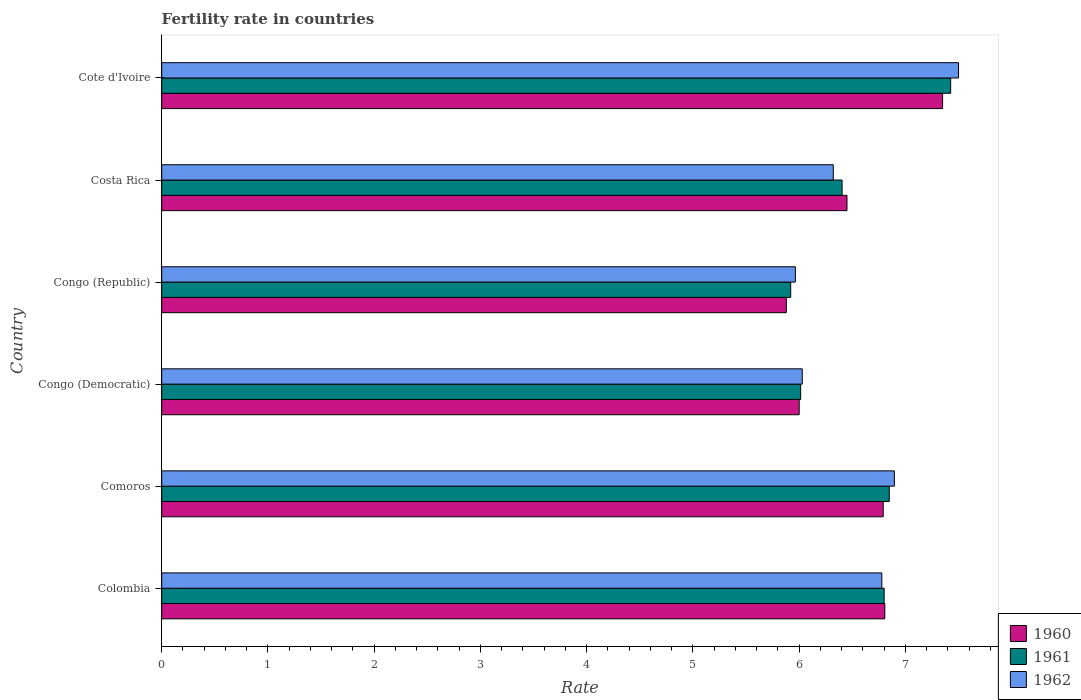How many different coloured bars are there?
Make the answer very short. 3. Are the number of bars per tick equal to the number of legend labels?
Your response must be concise. Yes. Are the number of bars on each tick of the Y-axis equal?
Make the answer very short. Yes. How many bars are there on the 6th tick from the bottom?
Offer a terse response. 3. What is the label of the 2nd group of bars from the top?
Provide a succinct answer. Costa Rica. What is the fertility rate in 1960 in Congo (Democratic)?
Ensure brevity in your answer.  6. Across all countries, what is the maximum fertility rate in 1960?
Your answer should be very brief. 7.35. Across all countries, what is the minimum fertility rate in 1961?
Provide a succinct answer. 5.92. In which country was the fertility rate in 1962 maximum?
Offer a very short reply. Cote d'Ivoire. In which country was the fertility rate in 1962 minimum?
Offer a terse response. Congo (Republic). What is the total fertility rate in 1960 in the graph?
Offer a very short reply. 39.28. What is the difference between the fertility rate in 1960 in Congo (Republic) and that in Costa Rica?
Provide a short and direct response. -0.57. What is the difference between the fertility rate in 1960 in Congo (Democratic) and the fertility rate in 1961 in Costa Rica?
Provide a succinct answer. -0.4. What is the average fertility rate in 1960 per country?
Offer a terse response. 6.55. What is the difference between the fertility rate in 1960 and fertility rate in 1961 in Costa Rica?
Offer a very short reply. 0.05. In how many countries, is the fertility rate in 1961 greater than 3.2 ?
Provide a short and direct response. 6. What is the ratio of the fertility rate in 1961 in Congo (Republic) to that in Cote d'Ivoire?
Give a very brief answer. 0.8. What is the difference between the highest and the second highest fertility rate in 1962?
Make the answer very short. 0.6. What is the difference between the highest and the lowest fertility rate in 1961?
Your response must be concise. 1.51. In how many countries, is the fertility rate in 1961 greater than the average fertility rate in 1961 taken over all countries?
Ensure brevity in your answer.  3. Is the sum of the fertility rate in 1962 in Comoros and Congo (Democratic) greater than the maximum fertility rate in 1960 across all countries?
Ensure brevity in your answer.  Yes. What does the 2nd bar from the top in Colombia represents?
Ensure brevity in your answer.  1961. Is it the case that in every country, the sum of the fertility rate in 1960 and fertility rate in 1961 is greater than the fertility rate in 1962?
Offer a very short reply. Yes. How many countries are there in the graph?
Ensure brevity in your answer.  6. Are the values on the major ticks of X-axis written in scientific E-notation?
Make the answer very short. No. Does the graph contain grids?
Ensure brevity in your answer.  No. Where does the legend appear in the graph?
Offer a terse response. Bottom right. How many legend labels are there?
Provide a succinct answer. 3. How are the legend labels stacked?
Ensure brevity in your answer.  Vertical. What is the title of the graph?
Provide a short and direct response. Fertility rate in countries. What is the label or title of the X-axis?
Provide a short and direct response. Rate. What is the label or title of the Y-axis?
Give a very brief answer. Country. What is the Rate in 1960 in Colombia?
Offer a terse response. 6.81. What is the Rate in 1961 in Colombia?
Ensure brevity in your answer.  6.8. What is the Rate in 1962 in Colombia?
Offer a very short reply. 6.78. What is the Rate in 1960 in Comoros?
Your response must be concise. 6.79. What is the Rate of 1961 in Comoros?
Offer a terse response. 6.85. What is the Rate in 1962 in Comoros?
Provide a short and direct response. 6.9. What is the Rate in 1960 in Congo (Democratic)?
Provide a succinct answer. 6. What is the Rate in 1961 in Congo (Democratic)?
Provide a succinct answer. 6.01. What is the Rate in 1962 in Congo (Democratic)?
Make the answer very short. 6.03. What is the Rate in 1960 in Congo (Republic)?
Offer a terse response. 5.88. What is the Rate in 1961 in Congo (Republic)?
Provide a succinct answer. 5.92. What is the Rate in 1962 in Congo (Republic)?
Ensure brevity in your answer.  5.96. What is the Rate in 1960 in Costa Rica?
Ensure brevity in your answer.  6.45. What is the Rate in 1961 in Costa Rica?
Provide a succinct answer. 6.41. What is the Rate of 1962 in Costa Rica?
Give a very brief answer. 6.32. What is the Rate of 1960 in Cote d'Ivoire?
Offer a very short reply. 7.35. What is the Rate of 1961 in Cote d'Ivoire?
Provide a short and direct response. 7.43. What is the Rate in 1962 in Cote d'Ivoire?
Offer a very short reply. 7.5. Across all countries, what is the maximum Rate in 1960?
Offer a very short reply. 7.35. Across all countries, what is the maximum Rate of 1961?
Your response must be concise. 7.43. Across all countries, what is the maximum Rate in 1962?
Your answer should be very brief. 7.5. Across all countries, what is the minimum Rate in 1960?
Your answer should be very brief. 5.88. Across all countries, what is the minimum Rate in 1961?
Make the answer very short. 5.92. Across all countries, what is the minimum Rate of 1962?
Your answer should be very brief. 5.96. What is the total Rate of 1960 in the graph?
Ensure brevity in your answer.  39.28. What is the total Rate in 1961 in the graph?
Offer a very short reply. 39.42. What is the total Rate of 1962 in the graph?
Your answer should be very brief. 39.49. What is the difference between the Rate in 1960 in Colombia and that in Comoros?
Provide a succinct answer. 0.01. What is the difference between the Rate in 1961 in Colombia and that in Comoros?
Your response must be concise. -0.05. What is the difference between the Rate of 1962 in Colombia and that in Comoros?
Give a very brief answer. -0.12. What is the difference between the Rate of 1960 in Colombia and that in Congo (Democratic)?
Your answer should be compact. 0.81. What is the difference between the Rate in 1961 in Colombia and that in Congo (Democratic)?
Ensure brevity in your answer.  0.79. What is the difference between the Rate of 1962 in Colombia and that in Congo (Democratic)?
Offer a very short reply. 0.75. What is the difference between the Rate in 1960 in Colombia and that in Congo (Republic)?
Offer a terse response. 0.93. What is the difference between the Rate of 1962 in Colombia and that in Congo (Republic)?
Make the answer very short. 0.81. What is the difference between the Rate of 1960 in Colombia and that in Costa Rica?
Your response must be concise. 0.36. What is the difference between the Rate in 1961 in Colombia and that in Costa Rica?
Provide a succinct answer. 0.4. What is the difference between the Rate of 1962 in Colombia and that in Costa Rica?
Give a very brief answer. 0.46. What is the difference between the Rate of 1960 in Colombia and that in Cote d'Ivoire?
Provide a short and direct response. -0.54. What is the difference between the Rate in 1961 in Colombia and that in Cote d'Ivoire?
Provide a short and direct response. -0.63. What is the difference between the Rate in 1962 in Colombia and that in Cote d'Ivoire?
Your response must be concise. -0.72. What is the difference between the Rate of 1960 in Comoros and that in Congo (Democratic)?
Ensure brevity in your answer.  0.79. What is the difference between the Rate of 1961 in Comoros and that in Congo (Democratic)?
Your answer should be very brief. 0.83. What is the difference between the Rate of 1962 in Comoros and that in Congo (Democratic)?
Provide a succinct answer. 0.87. What is the difference between the Rate of 1960 in Comoros and that in Congo (Republic)?
Your answer should be compact. 0.91. What is the difference between the Rate in 1961 in Comoros and that in Congo (Republic)?
Your answer should be very brief. 0.93. What is the difference between the Rate of 1962 in Comoros and that in Congo (Republic)?
Provide a short and direct response. 0.93. What is the difference between the Rate in 1960 in Comoros and that in Costa Rica?
Offer a terse response. 0.34. What is the difference between the Rate in 1961 in Comoros and that in Costa Rica?
Ensure brevity in your answer.  0.44. What is the difference between the Rate of 1962 in Comoros and that in Costa Rica?
Keep it short and to the point. 0.57. What is the difference between the Rate in 1960 in Comoros and that in Cote d'Ivoire?
Make the answer very short. -0.56. What is the difference between the Rate in 1961 in Comoros and that in Cote d'Ivoire?
Your answer should be compact. -0.58. What is the difference between the Rate of 1962 in Comoros and that in Cote d'Ivoire?
Your response must be concise. -0.6. What is the difference between the Rate in 1960 in Congo (Democratic) and that in Congo (Republic)?
Give a very brief answer. 0.12. What is the difference between the Rate of 1961 in Congo (Democratic) and that in Congo (Republic)?
Provide a short and direct response. 0.09. What is the difference between the Rate in 1962 in Congo (Democratic) and that in Congo (Republic)?
Make the answer very short. 0.07. What is the difference between the Rate of 1960 in Congo (Democratic) and that in Costa Rica?
Make the answer very short. -0.45. What is the difference between the Rate of 1961 in Congo (Democratic) and that in Costa Rica?
Provide a short and direct response. -0.39. What is the difference between the Rate in 1962 in Congo (Democratic) and that in Costa Rica?
Your answer should be very brief. -0.29. What is the difference between the Rate of 1960 in Congo (Democratic) and that in Cote d'Ivoire?
Your answer should be very brief. -1.35. What is the difference between the Rate of 1961 in Congo (Democratic) and that in Cote d'Ivoire?
Keep it short and to the point. -1.41. What is the difference between the Rate in 1962 in Congo (Democratic) and that in Cote d'Ivoire?
Provide a succinct answer. -1.47. What is the difference between the Rate in 1960 in Congo (Republic) and that in Costa Rica?
Offer a terse response. -0.57. What is the difference between the Rate in 1961 in Congo (Republic) and that in Costa Rica?
Make the answer very short. -0.48. What is the difference between the Rate of 1962 in Congo (Republic) and that in Costa Rica?
Your response must be concise. -0.36. What is the difference between the Rate of 1960 in Congo (Republic) and that in Cote d'Ivoire?
Keep it short and to the point. -1.47. What is the difference between the Rate of 1961 in Congo (Republic) and that in Cote d'Ivoire?
Provide a short and direct response. -1.51. What is the difference between the Rate in 1962 in Congo (Republic) and that in Cote d'Ivoire?
Ensure brevity in your answer.  -1.54. What is the difference between the Rate in 1960 in Costa Rica and that in Cote d'Ivoire?
Your response must be concise. -0.9. What is the difference between the Rate in 1961 in Costa Rica and that in Cote d'Ivoire?
Ensure brevity in your answer.  -1.02. What is the difference between the Rate in 1962 in Costa Rica and that in Cote d'Ivoire?
Provide a short and direct response. -1.18. What is the difference between the Rate of 1960 in Colombia and the Rate of 1961 in Comoros?
Your answer should be very brief. -0.04. What is the difference between the Rate in 1960 in Colombia and the Rate in 1962 in Comoros?
Give a very brief answer. -0.09. What is the difference between the Rate of 1961 in Colombia and the Rate of 1962 in Comoros?
Your answer should be compact. -0.1. What is the difference between the Rate in 1960 in Colombia and the Rate in 1961 in Congo (Democratic)?
Your response must be concise. 0.79. What is the difference between the Rate in 1960 in Colombia and the Rate in 1962 in Congo (Democratic)?
Offer a terse response. 0.78. What is the difference between the Rate in 1961 in Colombia and the Rate in 1962 in Congo (Democratic)?
Offer a terse response. 0.77. What is the difference between the Rate of 1960 in Colombia and the Rate of 1961 in Congo (Republic)?
Provide a short and direct response. 0.89. What is the difference between the Rate of 1960 in Colombia and the Rate of 1962 in Congo (Republic)?
Your answer should be very brief. 0.84. What is the difference between the Rate in 1961 in Colombia and the Rate in 1962 in Congo (Republic)?
Your response must be concise. 0.84. What is the difference between the Rate of 1960 in Colombia and the Rate of 1961 in Costa Rica?
Provide a short and direct response. 0.4. What is the difference between the Rate of 1960 in Colombia and the Rate of 1962 in Costa Rica?
Offer a terse response. 0.48. What is the difference between the Rate of 1961 in Colombia and the Rate of 1962 in Costa Rica?
Provide a short and direct response. 0.48. What is the difference between the Rate of 1960 in Colombia and the Rate of 1961 in Cote d'Ivoire?
Make the answer very short. -0.62. What is the difference between the Rate in 1960 in Colombia and the Rate in 1962 in Cote d'Ivoire?
Provide a short and direct response. -0.69. What is the difference between the Rate of 1961 in Colombia and the Rate of 1962 in Cote d'Ivoire?
Provide a succinct answer. -0.7. What is the difference between the Rate of 1960 in Comoros and the Rate of 1961 in Congo (Democratic)?
Make the answer very short. 0.78. What is the difference between the Rate of 1960 in Comoros and the Rate of 1962 in Congo (Democratic)?
Give a very brief answer. 0.76. What is the difference between the Rate of 1961 in Comoros and the Rate of 1962 in Congo (Democratic)?
Provide a succinct answer. 0.82. What is the difference between the Rate of 1960 in Comoros and the Rate of 1961 in Congo (Republic)?
Your answer should be compact. 0.87. What is the difference between the Rate of 1960 in Comoros and the Rate of 1962 in Congo (Republic)?
Offer a very short reply. 0.83. What is the difference between the Rate in 1961 in Comoros and the Rate in 1962 in Congo (Republic)?
Ensure brevity in your answer.  0.88. What is the difference between the Rate of 1960 in Comoros and the Rate of 1961 in Costa Rica?
Provide a succinct answer. 0.39. What is the difference between the Rate in 1960 in Comoros and the Rate in 1962 in Costa Rica?
Give a very brief answer. 0.47. What is the difference between the Rate of 1961 in Comoros and the Rate of 1962 in Costa Rica?
Your answer should be very brief. 0.53. What is the difference between the Rate of 1960 in Comoros and the Rate of 1961 in Cote d'Ivoire?
Provide a short and direct response. -0.64. What is the difference between the Rate of 1960 in Comoros and the Rate of 1962 in Cote d'Ivoire?
Provide a short and direct response. -0.71. What is the difference between the Rate in 1961 in Comoros and the Rate in 1962 in Cote d'Ivoire?
Give a very brief answer. -0.65. What is the difference between the Rate in 1960 in Congo (Democratic) and the Rate in 1961 in Congo (Republic)?
Provide a short and direct response. 0.08. What is the difference between the Rate in 1960 in Congo (Democratic) and the Rate in 1962 in Congo (Republic)?
Your answer should be very brief. 0.04. What is the difference between the Rate of 1961 in Congo (Democratic) and the Rate of 1962 in Congo (Republic)?
Provide a succinct answer. 0.05. What is the difference between the Rate of 1960 in Congo (Democratic) and the Rate of 1961 in Costa Rica?
Your answer should be very brief. -0.4. What is the difference between the Rate in 1960 in Congo (Democratic) and the Rate in 1962 in Costa Rica?
Provide a succinct answer. -0.32. What is the difference between the Rate of 1961 in Congo (Democratic) and the Rate of 1962 in Costa Rica?
Offer a very short reply. -0.31. What is the difference between the Rate of 1960 in Congo (Democratic) and the Rate of 1961 in Cote d'Ivoire?
Keep it short and to the point. -1.43. What is the difference between the Rate of 1961 in Congo (Democratic) and the Rate of 1962 in Cote d'Ivoire?
Ensure brevity in your answer.  -1.49. What is the difference between the Rate in 1960 in Congo (Republic) and the Rate in 1961 in Costa Rica?
Provide a succinct answer. -0.53. What is the difference between the Rate of 1960 in Congo (Republic) and the Rate of 1962 in Costa Rica?
Provide a short and direct response. -0.44. What is the difference between the Rate of 1961 in Congo (Republic) and the Rate of 1962 in Costa Rica?
Ensure brevity in your answer.  -0.4. What is the difference between the Rate in 1960 in Congo (Republic) and the Rate in 1961 in Cote d'Ivoire?
Keep it short and to the point. -1.55. What is the difference between the Rate in 1960 in Congo (Republic) and the Rate in 1962 in Cote d'Ivoire?
Offer a very short reply. -1.62. What is the difference between the Rate of 1961 in Congo (Republic) and the Rate of 1962 in Cote d'Ivoire?
Provide a short and direct response. -1.58. What is the difference between the Rate in 1960 in Costa Rica and the Rate in 1961 in Cote d'Ivoire?
Provide a succinct answer. -0.98. What is the difference between the Rate in 1960 in Costa Rica and the Rate in 1962 in Cote d'Ivoire?
Ensure brevity in your answer.  -1.05. What is the difference between the Rate in 1961 in Costa Rica and the Rate in 1962 in Cote d'Ivoire?
Offer a very short reply. -1.1. What is the average Rate of 1960 per country?
Your response must be concise. 6.55. What is the average Rate in 1961 per country?
Provide a succinct answer. 6.57. What is the average Rate of 1962 per country?
Offer a terse response. 6.58. What is the difference between the Rate of 1960 and Rate of 1961 in Colombia?
Provide a succinct answer. 0.01. What is the difference between the Rate in 1960 and Rate in 1962 in Colombia?
Make the answer very short. 0.03. What is the difference between the Rate in 1961 and Rate in 1962 in Colombia?
Provide a short and direct response. 0.02. What is the difference between the Rate in 1960 and Rate in 1961 in Comoros?
Make the answer very short. -0.06. What is the difference between the Rate in 1960 and Rate in 1962 in Comoros?
Ensure brevity in your answer.  -0.1. What is the difference between the Rate in 1961 and Rate in 1962 in Comoros?
Your answer should be very brief. -0.05. What is the difference between the Rate of 1960 and Rate of 1961 in Congo (Democratic)?
Your answer should be compact. -0.01. What is the difference between the Rate in 1960 and Rate in 1962 in Congo (Democratic)?
Provide a short and direct response. -0.03. What is the difference between the Rate of 1961 and Rate of 1962 in Congo (Democratic)?
Provide a short and direct response. -0.01. What is the difference between the Rate in 1960 and Rate in 1961 in Congo (Republic)?
Give a very brief answer. -0.04. What is the difference between the Rate of 1960 and Rate of 1962 in Congo (Republic)?
Offer a very short reply. -0.09. What is the difference between the Rate in 1961 and Rate in 1962 in Congo (Republic)?
Make the answer very short. -0.04. What is the difference between the Rate in 1960 and Rate in 1961 in Costa Rica?
Provide a succinct answer. 0.05. What is the difference between the Rate in 1960 and Rate in 1962 in Costa Rica?
Provide a succinct answer. 0.13. What is the difference between the Rate of 1961 and Rate of 1962 in Costa Rica?
Give a very brief answer. 0.08. What is the difference between the Rate of 1960 and Rate of 1961 in Cote d'Ivoire?
Your answer should be very brief. -0.08. What is the difference between the Rate in 1960 and Rate in 1962 in Cote d'Ivoire?
Ensure brevity in your answer.  -0.15. What is the difference between the Rate of 1961 and Rate of 1962 in Cote d'Ivoire?
Give a very brief answer. -0.07. What is the ratio of the Rate of 1961 in Colombia to that in Comoros?
Ensure brevity in your answer.  0.99. What is the ratio of the Rate in 1962 in Colombia to that in Comoros?
Offer a terse response. 0.98. What is the ratio of the Rate of 1960 in Colombia to that in Congo (Democratic)?
Offer a terse response. 1.13. What is the ratio of the Rate in 1961 in Colombia to that in Congo (Democratic)?
Ensure brevity in your answer.  1.13. What is the ratio of the Rate in 1962 in Colombia to that in Congo (Democratic)?
Your answer should be compact. 1.12. What is the ratio of the Rate of 1960 in Colombia to that in Congo (Republic)?
Offer a terse response. 1.16. What is the ratio of the Rate of 1961 in Colombia to that in Congo (Republic)?
Provide a succinct answer. 1.15. What is the ratio of the Rate in 1962 in Colombia to that in Congo (Republic)?
Provide a short and direct response. 1.14. What is the ratio of the Rate in 1960 in Colombia to that in Costa Rica?
Your answer should be very brief. 1.06. What is the ratio of the Rate of 1961 in Colombia to that in Costa Rica?
Your answer should be compact. 1.06. What is the ratio of the Rate in 1962 in Colombia to that in Costa Rica?
Your answer should be compact. 1.07. What is the ratio of the Rate in 1960 in Colombia to that in Cote d'Ivoire?
Ensure brevity in your answer.  0.93. What is the ratio of the Rate of 1961 in Colombia to that in Cote d'Ivoire?
Make the answer very short. 0.92. What is the ratio of the Rate of 1962 in Colombia to that in Cote d'Ivoire?
Give a very brief answer. 0.9. What is the ratio of the Rate in 1960 in Comoros to that in Congo (Democratic)?
Keep it short and to the point. 1.13. What is the ratio of the Rate of 1961 in Comoros to that in Congo (Democratic)?
Offer a terse response. 1.14. What is the ratio of the Rate in 1962 in Comoros to that in Congo (Democratic)?
Offer a very short reply. 1.14. What is the ratio of the Rate of 1960 in Comoros to that in Congo (Republic)?
Provide a succinct answer. 1.16. What is the ratio of the Rate in 1961 in Comoros to that in Congo (Republic)?
Keep it short and to the point. 1.16. What is the ratio of the Rate of 1962 in Comoros to that in Congo (Republic)?
Provide a succinct answer. 1.16. What is the ratio of the Rate of 1960 in Comoros to that in Costa Rica?
Offer a terse response. 1.05. What is the ratio of the Rate in 1961 in Comoros to that in Costa Rica?
Your answer should be very brief. 1.07. What is the ratio of the Rate of 1962 in Comoros to that in Costa Rica?
Give a very brief answer. 1.09. What is the ratio of the Rate of 1960 in Comoros to that in Cote d'Ivoire?
Ensure brevity in your answer.  0.92. What is the ratio of the Rate in 1961 in Comoros to that in Cote d'Ivoire?
Offer a very short reply. 0.92. What is the ratio of the Rate in 1962 in Comoros to that in Cote d'Ivoire?
Offer a terse response. 0.92. What is the ratio of the Rate of 1960 in Congo (Democratic) to that in Congo (Republic)?
Give a very brief answer. 1.02. What is the ratio of the Rate of 1961 in Congo (Democratic) to that in Congo (Republic)?
Ensure brevity in your answer.  1.02. What is the ratio of the Rate of 1962 in Congo (Democratic) to that in Congo (Republic)?
Give a very brief answer. 1.01. What is the ratio of the Rate in 1960 in Congo (Democratic) to that in Costa Rica?
Give a very brief answer. 0.93. What is the ratio of the Rate in 1961 in Congo (Democratic) to that in Costa Rica?
Offer a terse response. 0.94. What is the ratio of the Rate in 1962 in Congo (Democratic) to that in Costa Rica?
Your response must be concise. 0.95. What is the ratio of the Rate in 1960 in Congo (Democratic) to that in Cote d'Ivoire?
Provide a succinct answer. 0.82. What is the ratio of the Rate of 1961 in Congo (Democratic) to that in Cote d'Ivoire?
Your answer should be very brief. 0.81. What is the ratio of the Rate of 1962 in Congo (Democratic) to that in Cote d'Ivoire?
Offer a very short reply. 0.8. What is the ratio of the Rate in 1960 in Congo (Republic) to that in Costa Rica?
Provide a succinct answer. 0.91. What is the ratio of the Rate of 1961 in Congo (Republic) to that in Costa Rica?
Offer a very short reply. 0.92. What is the ratio of the Rate in 1962 in Congo (Republic) to that in Costa Rica?
Provide a succinct answer. 0.94. What is the ratio of the Rate in 1960 in Congo (Republic) to that in Cote d'Ivoire?
Ensure brevity in your answer.  0.8. What is the ratio of the Rate of 1961 in Congo (Republic) to that in Cote d'Ivoire?
Your response must be concise. 0.8. What is the ratio of the Rate of 1962 in Congo (Republic) to that in Cote d'Ivoire?
Your answer should be very brief. 0.8. What is the ratio of the Rate in 1960 in Costa Rica to that in Cote d'Ivoire?
Your answer should be very brief. 0.88. What is the ratio of the Rate in 1961 in Costa Rica to that in Cote d'Ivoire?
Provide a succinct answer. 0.86. What is the ratio of the Rate in 1962 in Costa Rica to that in Cote d'Ivoire?
Offer a terse response. 0.84. What is the difference between the highest and the second highest Rate in 1960?
Make the answer very short. 0.54. What is the difference between the highest and the second highest Rate in 1961?
Offer a terse response. 0.58. What is the difference between the highest and the second highest Rate in 1962?
Make the answer very short. 0.6. What is the difference between the highest and the lowest Rate in 1960?
Give a very brief answer. 1.47. What is the difference between the highest and the lowest Rate of 1961?
Your answer should be very brief. 1.51. What is the difference between the highest and the lowest Rate in 1962?
Provide a short and direct response. 1.54. 